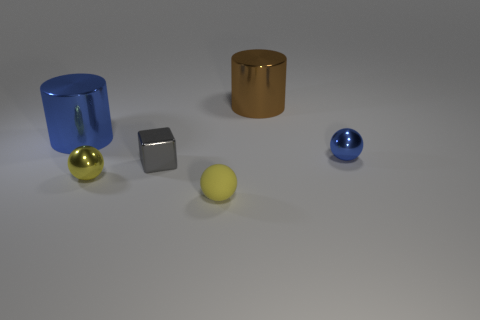Add 4 cyan matte spheres. How many objects exist? 10 Subtract all blocks. How many objects are left? 5 Add 2 tiny yellow shiny objects. How many tiny yellow shiny objects exist? 3 Subtract 0 cyan cylinders. How many objects are left? 6 Subtract all tiny gray matte cylinders. Subtract all large blue metal objects. How many objects are left? 5 Add 4 small yellow objects. How many small yellow objects are left? 6 